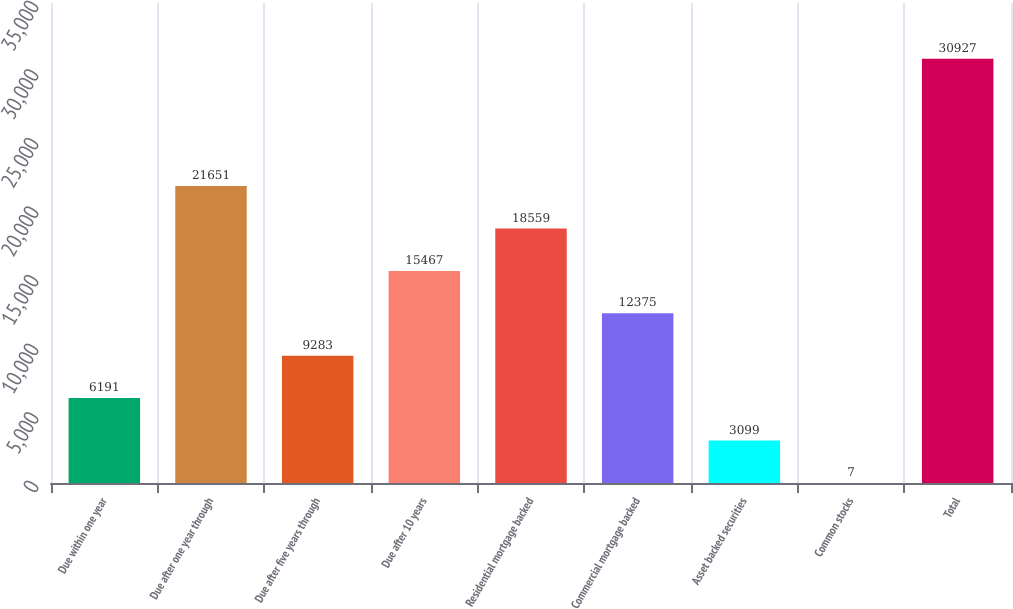Convert chart. <chart><loc_0><loc_0><loc_500><loc_500><bar_chart><fcel>Due within one year<fcel>Due after one year through<fcel>Due after five years through<fcel>Due after 10 years<fcel>Residential mortgage backed<fcel>Commercial mortgage backed<fcel>Asset backed securities<fcel>Common stocks<fcel>Total<nl><fcel>6191<fcel>21651<fcel>9283<fcel>15467<fcel>18559<fcel>12375<fcel>3099<fcel>7<fcel>30927<nl></chart> 